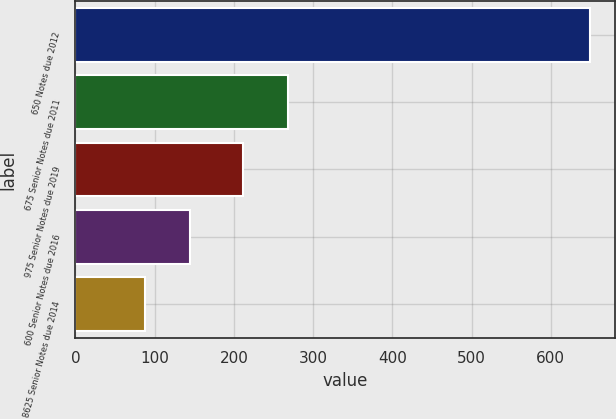Convert chart. <chart><loc_0><loc_0><loc_500><loc_500><bar_chart><fcel>650 Notes due 2012<fcel>675 Senior Notes due 2011<fcel>975 Senior Notes due 2019<fcel>600 Senior Notes due 2016<fcel>8625 Senior Notes due 2014<nl><fcel>649<fcel>268.1<fcel>212<fcel>144.1<fcel>88<nl></chart> 